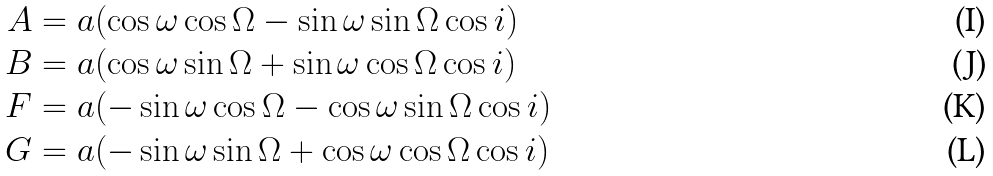<formula> <loc_0><loc_0><loc_500><loc_500>A & = a ( \cos \omega \cos \Omega - \sin \omega \sin \Omega \cos i ) \\ B & = a ( \cos \omega \sin \Omega + \sin \omega \cos \Omega \cos i ) \\ F & = a ( - \sin \omega \cos \Omega - \cos \omega \sin \Omega \cos i ) \\ G & = a ( - \sin \omega \sin \Omega + \cos \omega \cos \Omega \cos i )</formula> 